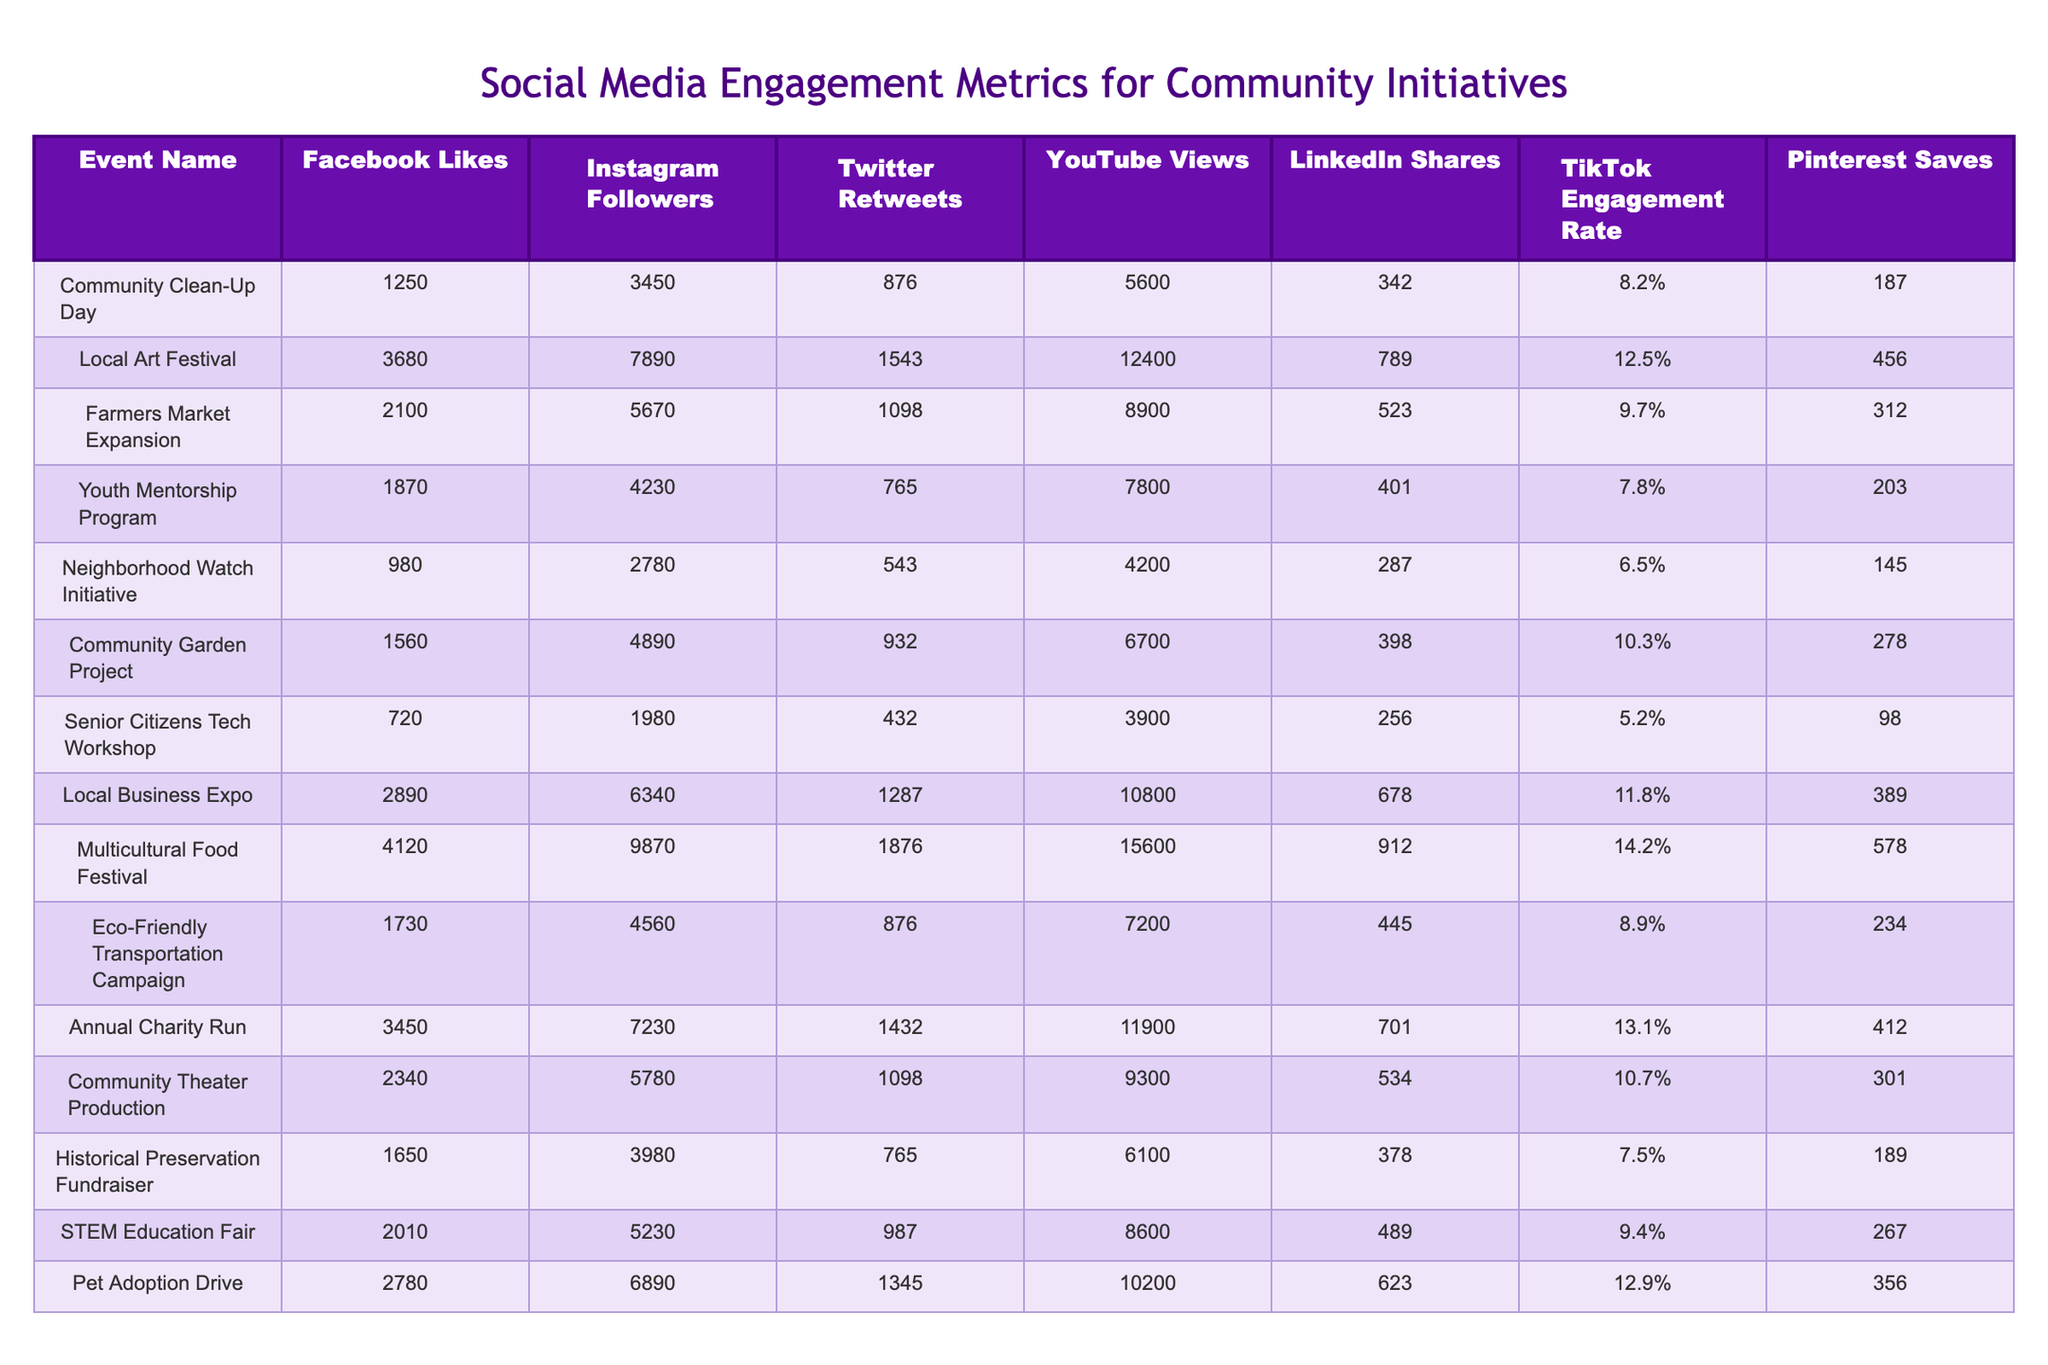What event had the highest number of Facebook likes? By examining the "Facebook Likes" column, the "Local Art Festival" shows the highest value of 3680.
Answer: Local Art Festival How many TikTok Engagement Rate percentages are above 10%? By reviewing the TikTok Engagement Rate column, the events with rates above 10% are the "Local Art Festival" (12.5%), "Multicultural Food Festival" (14.2%), "Annual Charity Run" (13.1%), and "Pet Adoption Drive" (12.9%), totaling four events.
Answer: 4 What is the event with the fewest Twitter Retweets? Looking at the "Twitter Retweets" column, the "Neighborhood Watch Initiative" has the lowest value with 543 retweets.
Answer: Neighborhood Watch Initiative What is the average number of YouTube Views across all events? By adding the total YouTube Views: 5600 + 12400 + 8900 + 7800 + 4200 + 6700 + 3900 + 10800 + 15600 + 7200 + 11900 + 9300 + 6100 + 8600 + 10200 = 106200, and dividing by the number of events (15), we get an average of 7080.
Answer: 7080 How many events had less than 300 shares on LinkedIn? The "LinkedIn Shares" column reveals that the "Neighborhood Watch Initiative" (287), "Senior Citizens Tech Workshop" (256), and "Historical Preservation Fundraiser" (378) are four events below 300 shares.
Answer: 2 Which social media platform had the most engagement for the "Community Garden Project"? By checking the columns, the "Community Garden Project" had 4890 Instagram followers, which is higher than its Facebook likes (1560) and TikTok engagement rate (10.3%).
Answer: Instagram Is there an event that has more YouTube Views than Facebook Likes? When comparing the columns, yes, the "Local Art Festival" (12400 views vs 3680 likes), "Farmers Market Expansion" (8900 views vs 2100 likes), "Pet Adoption Drive" (10200 views vs 2780 likes) have more views than likes.
Answer: Yes What is the total number of Instagram followers for events with more than 2000 Facebook Likes? Looking at the events with more than 2000 likes: "Local Art Festival" (7890), "Farmers Market Expansion" (5670), "Local Business Expo" (6340), "Pet Adoption Drive" (6890), and "Annual Charity Run" (7230). Summing them gives 7890 + 5670 + 6340 + 6890 + 7230 = 40990 Instagram followers.
Answer: 40990 Which event had the least engagement on TikTok? Reviewing the TikTok Engagement Rate column, the "Senior Citizens Tech Workshop" has the lowest engagement rate at 5.2%.
Answer: Senior Citizens Tech Workshop What is the difference in Facebook Likes between the event with the highest and the lowest? The highest Facebook Likes is from "Local Art Festival" with 3680, and the lowest is from "Senior Citizens Tech Workshop" with 720. Thus, the difference is 3680 - 720 = 2960.
Answer: 2960 